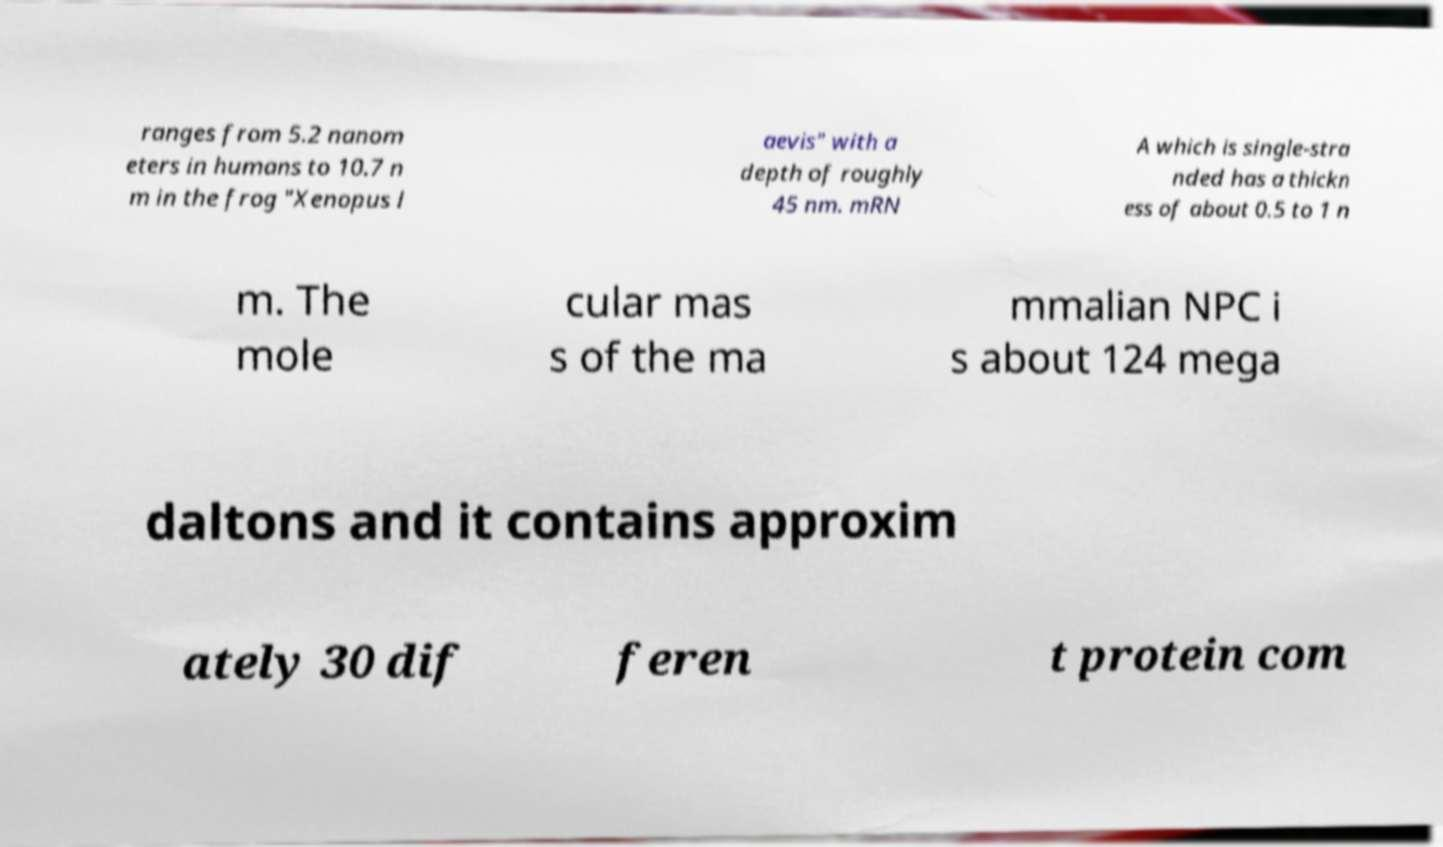For documentation purposes, I need the text within this image transcribed. Could you provide that? ranges from 5.2 nanom eters in humans to 10.7 n m in the frog "Xenopus l aevis" with a depth of roughly 45 nm. mRN A which is single-stra nded has a thickn ess of about 0.5 to 1 n m. The mole cular mas s of the ma mmalian NPC i s about 124 mega daltons and it contains approxim ately 30 dif feren t protein com 